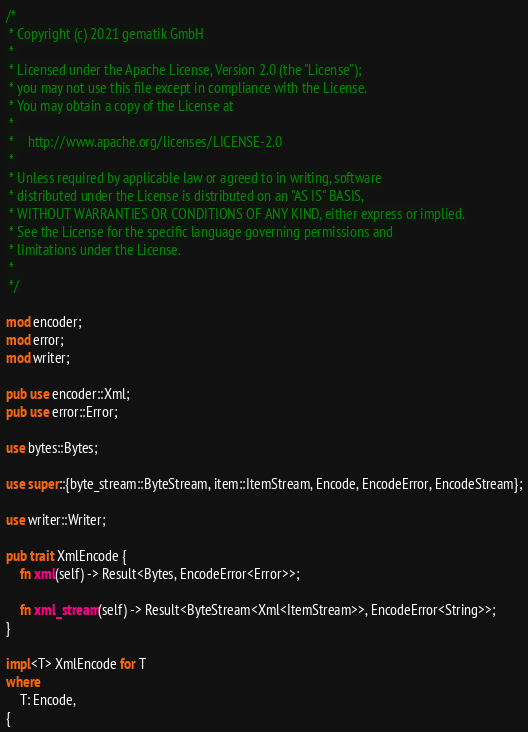<code> <loc_0><loc_0><loc_500><loc_500><_Rust_>/*
 * Copyright (c) 2021 gematik GmbH
 * 
 * Licensed under the Apache License, Version 2.0 (the "License");
 * you may not use this file except in compliance with the License.
 * You may obtain a copy of the License at
 * 
 *    http://www.apache.org/licenses/LICENSE-2.0
 * 
 * Unless required by applicable law or agreed to in writing, software
 * distributed under the License is distributed on an "AS IS" BASIS,
 * WITHOUT WARRANTIES OR CONDITIONS OF ANY KIND, either express or implied.
 * See the License for the specific language governing permissions and
 * limitations under the License.
 *
 */

mod encoder;
mod error;
mod writer;

pub use encoder::Xml;
pub use error::Error;

use bytes::Bytes;

use super::{byte_stream::ByteStream, item::ItemStream, Encode, EncodeError, EncodeStream};

use writer::Writer;

pub trait XmlEncode {
    fn xml(self) -> Result<Bytes, EncodeError<Error>>;

    fn xml_stream(self) -> Result<ByteStream<Xml<ItemStream>>, EncodeError<String>>;
}

impl<T> XmlEncode for T
where
    T: Encode,
{</code> 